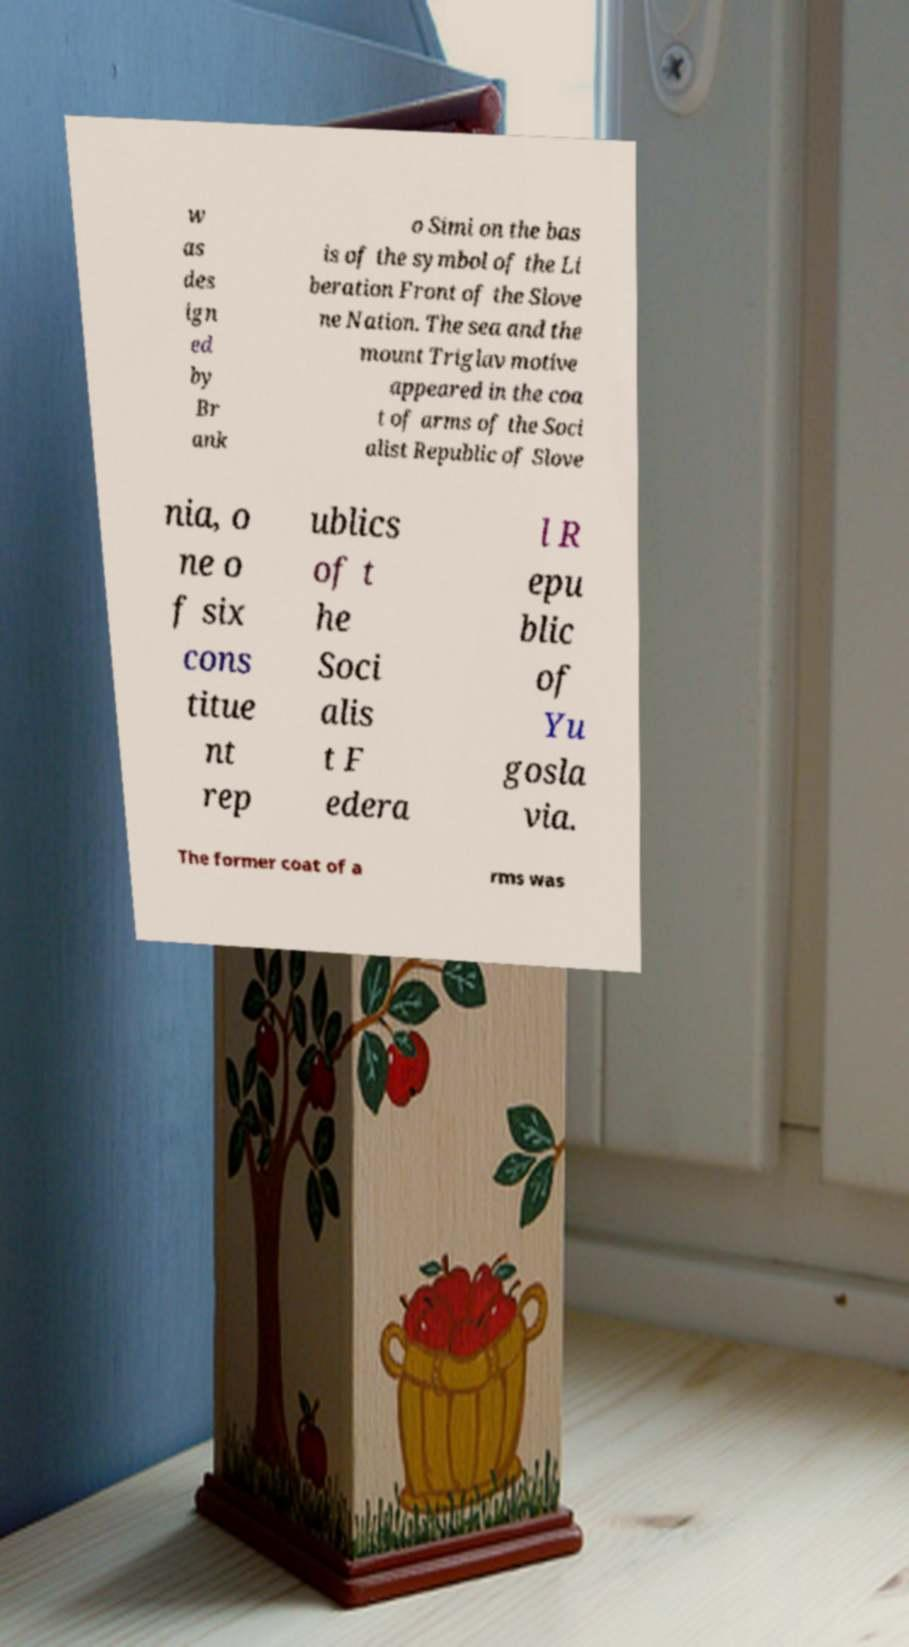Could you extract and type out the text from this image? w as des ign ed by Br ank o Simi on the bas is of the symbol of the Li beration Front of the Slove ne Nation. The sea and the mount Triglav motive appeared in the coa t of arms of the Soci alist Republic of Slove nia, o ne o f six cons titue nt rep ublics of t he Soci alis t F edera l R epu blic of Yu gosla via. The former coat of a rms was 